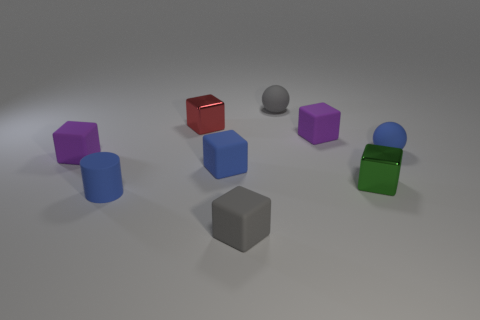Subtract 1 blocks. How many blocks are left? 5 Subtract all gray blocks. How many blocks are left? 5 Subtract all tiny red blocks. How many blocks are left? 5 Subtract all red blocks. Subtract all blue cylinders. How many blocks are left? 5 Subtract all cylinders. How many objects are left? 8 Add 3 blue things. How many blue things exist? 6 Subtract 1 gray spheres. How many objects are left? 8 Subtract all blue rubber balls. Subtract all big brown matte balls. How many objects are left? 8 Add 6 gray matte balls. How many gray matte balls are left? 7 